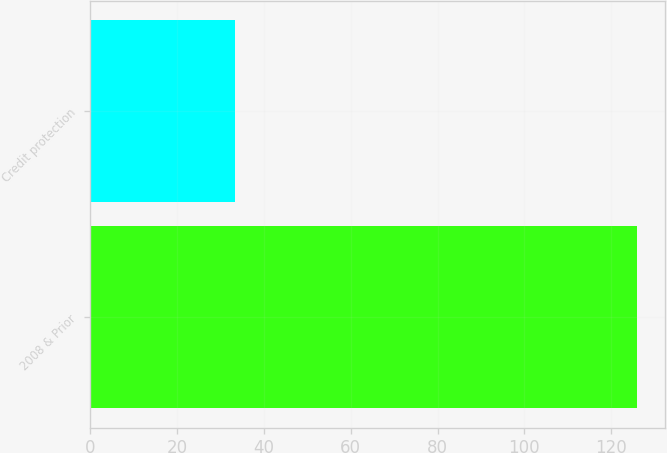Convert chart. <chart><loc_0><loc_0><loc_500><loc_500><bar_chart><fcel>2008 & Prior<fcel>Credit protection<nl><fcel>126<fcel>33.3<nl></chart> 